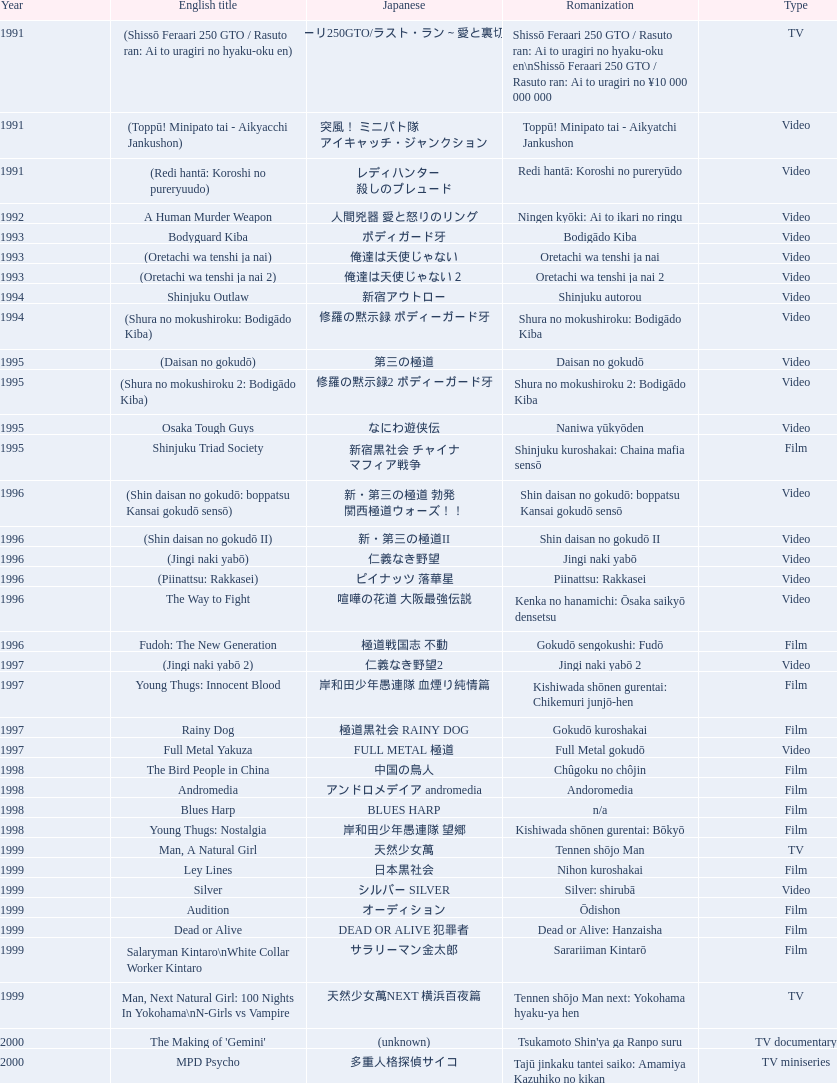Would you be able to parse every entry in this table? {'header': ['Year', 'English title', 'Japanese', 'Romanization', 'Type'], 'rows': [['1991', '(Shissō Feraari 250 GTO / Rasuto ran: Ai to uragiri no hyaku-oku en)', '疾走フェラーリ250GTO/ラスト・ラン～愛と裏切りの百億円', 'Shissō Feraari 250 GTO / Rasuto ran: Ai to uragiri no hyaku-oku en\\nShissō Feraari 250 GTO / Rasuto ran: Ai to uragiri no ¥10 000 000 000', 'TV'], ['1991', '(Toppū! Minipato tai - Aikyacchi Jankushon)', '突風！ ミニパト隊 アイキャッチ・ジャンクション', 'Toppū! Minipato tai - Aikyatchi Jankushon', 'Video'], ['1991', '(Redi hantā: Koroshi no pureryuudo)', 'レディハンター 殺しのプレュード', 'Redi hantā: Koroshi no pureryūdo', 'Video'], ['1992', 'A Human Murder Weapon', '人間兇器 愛と怒りのリング', 'Ningen kyōki: Ai to ikari no ringu', 'Video'], ['1993', 'Bodyguard Kiba', 'ボディガード牙', 'Bodigādo Kiba', 'Video'], ['1993', '(Oretachi wa tenshi ja nai)', '俺達は天使じゃない', 'Oretachi wa tenshi ja nai', 'Video'], ['1993', '(Oretachi wa tenshi ja nai 2)', '俺達は天使じゃない２', 'Oretachi wa tenshi ja nai 2', 'Video'], ['1994', 'Shinjuku Outlaw', '新宿アウトロー', 'Shinjuku autorou', 'Video'], ['1994', '(Shura no mokushiroku: Bodigādo Kiba)', '修羅の黙示録 ボディーガード牙', 'Shura no mokushiroku: Bodigādo Kiba', 'Video'], ['1995', '(Daisan no gokudō)', '第三の極道', 'Daisan no gokudō', 'Video'], ['1995', '(Shura no mokushiroku 2: Bodigādo Kiba)', '修羅の黙示録2 ボディーガード牙', 'Shura no mokushiroku 2: Bodigādo Kiba', 'Video'], ['1995', 'Osaka Tough Guys', 'なにわ遊侠伝', 'Naniwa yūkyōden', 'Video'], ['1995', 'Shinjuku Triad Society', '新宿黒社会 チャイナ マフィア戦争', 'Shinjuku kuroshakai: Chaina mafia sensō', 'Film'], ['1996', '(Shin daisan no gokudō: boppatsu Kansai gokudō sensō)', '新・第三の極道 勃発 関西極道ウォーズ！！', 'Shin daisan no gokudō: boppatsu Kansai gokudō sensō', 'Video'], ['1996', '(Shin daisan no gokudō II)', '新・第三の極道II', 'Shin daisan no gokudō II', 'Video'], ['1996', '(Jingi naki yabō)', '仁義なき野望', 'Jingi naki yabō', 'Video'], ['1996', '(Piinattsu: Rakkasei)', 'ピイナッツ 落華星', 'Piinattsu: Rakkasei', 'Video'], ['1996', 'The Way to Fight', '喧嘩の花道 大阪最強伝説', 'Kenka no hanamichi: Ōsaka saikyō densetsu', 'Video'], ['1996', 'Fudoh: The New Generation', '極道戦国志 不動', 'Gokudō sengokushi: Fudō', 'Film'], ['1997', '(Jingi naki yabō 2)', '仁義なき野望2', 'Jingi naki yabō 2', 'Video'], ['1997', 'Young Thugs: Innocent Blood', '岸和田少年愚連隊 血煙り純情篇', 'Kishiwada shōnen gurentai: Chikemuri junjō-hen', 'Film'], ['1997', 'Rainy Dog', '極道黒社会 RAINY DOG', 'Gokudō kuroshakai', 'Film'], ['1997', 'Full Metal Yakuza', 'FULL METAL 極道', 'Full Metal gokudō', 'Video'], ['1998', 'The Bird People in China', '中国の鳥人', 'Chûgoku no chôjin', 'Film'], ['1998', 'Andromedia', 'アンドロメデイア andromedia', 'Andoromedia', 'Film'], ['1998', 'Blues Harp', 'BLUES HARP', 'n/a', 'Film'], ['1998', 'Young Thugs: Nostalgia', '岸和田少年愚連隊 望郷', 'Kishiwada shōnen gurentai: Bōkyō', 'Film'], ['1999', 'Man, A Natural Girl', '天然少女萬', 'Tennen shōjo Man', 'TV'], ['1999', 'Ley Lines', '日本黒社会', 'Nihon kuroshakai', 'Film'], ['1999', 'Silver', 'シルバー SILVER', 'Silver: shirubā', 'Video'], ['1999', 'Audition', 'オーディション', 'Ōdishon', 'Film'], ['1999', 'Dead or Alive', 'DEAD OR ALIVE 犯罪者', 'Dead or Alive: Hanzaisha', 'Film'], ['1999', 'Salaryman Kintaro\\nWhite Collar Worker Kintaro', 'サラリーマン金太郎', 'Sarariiman Kintarō', 'Film'], ['1999', 'Man, Next Natural Girl: 100 Nights In Yokohama\\nN-Girls vs Vampire', '天然少女萬NEXT 横浜百夜篇', 'Tennen shōjo Man next: Yokohama hyaku-ya hen', 'TV'], ['2000', "The Making of 'Gemini'", '(unknown)', "Tsukamoto Shin'ya ga Ranpo suru", 'TV documentary'], ['2000', 'MPD Psycho', '多重人格探偵サイコ', 'Tajū jinkaku tantei saiko: Amamiya Kazuhiko no kikan', 'TV miniseries'], ['2000', 'The City of Lost Souls\\nThe City of Strangers\\nThe Hazard City', '漂流街 THE HAZARD CITY', 'Hyōryū-gai', 'Film'], ['2000', 'The Guys from Paradise', '天国から来た男たち', 'Tengoku kara kita otoko-tachi', 'Film'], ['2000', 'Dead or Alive 2: Birds\\nDead or Alive 2: Runaway', 'DEAD OR ALIVE 2 逃亡者', 'Dead or Alive 2: Tōbōsha', 'Film'], ['2001', '(Kikuchi-jō monogatari: sakimori-tachi no uta)', '鞠智城物語 防人たちの唄', 'Kikuchi-jō monogatari: sakimori-tachi no uta', 'Film'], ['2001', '(Zuiketsu gensō: Tonkararin yume densetsu)', '隧穴幻想 トンカラリン夢伝説', 'Zuiketsu gensō: Tonkararin yume densetsu', 'Film'], ['2001', 'Family', 'FAMILY', 'n/a', 'Film'], ['2001', 'Visitor Q', 'ビジターQ', 'Bijitā Q', 'Video'], ['2001', 'Ichi the Killer', '殺し屋1', 'Koroshiya 1', 'Film'], ['2001', 'Agitator', '荒ぶる魂たち', 'Araburu tamashii-tachi', 'Film'], ['2001', 'The Happiness of the Katakuris', 'カタクリ家の幸福', 'Katakuri-ke no kōfuku', 'Film'], ['2002', 'Dead or Alive: Final', 'DEAD OR ALIVE FINAL', 'n/a', 'Film'], ['2002', '(Onna kunishū ikki)', 'おんな 国衆一揆', 'Onna kunishū ikki', '(unknown)'], ['2002', 'Sabu', 'SABU さぶ', 'Sabu', 'TV'], ['2002', 'Graveyard of Honor', '新・仁義の墓場', 'Shin jingi no hakaba', 'Film'], ['2002', 'Shangri-La', '金融破滅ニッポン 桃源郷の人々', "Kin'yū hametsu Nippon: Tōgenkyō no hito-bito", 'Film'], ['2002', 'Pandōra', 'パンドーラ', 'Pandōra', 'Music video'], ['2002', 'Deadly Outlaw: Rekka\\nViolent Fire', '実録・安藤昇侠道（アウトロー）伝 烈火', 'Jitsuroku Andō Noboru kyōdō-den: Rekka', 'Film'], ['2002', 'Pāto-taimu tantei', 'パートタイム探偵', 'Pāto-taimu tantei', 'TV series'], ['2003', 'The Man in White', '許されざる者', 'Yurusarezaru mono', 'Film'], ['2003', 'Gozu', '極道恐怖大劇場 牛頭 GOZU', 'Gokudō kyōfu dai-gekijō: Gozu', 'Film'], ['2003', 'Yakuza Demon', '鬼哭 kikoku', 'Kikoku', 'Video'], ['2003', 'Kōshōnin', '交渉人', 'Kōshōnin', 'TV'], ['2003', "One Missed Call\\nYou've Got a Call", '着信アリ', 'Chakushin Ari', 'Film'], ['2004', 'Zebraman', 'ゼブラーマン', 'Zeburāman', 'Film'], ['2004', 'Pāto-taimu tantei 2', 'パートタイム探偵2', 'Pāto-taimu tantei 2', 'TV'], ['2004', 'Box segment in Three... Extremes', 'BOX（『美しい夜、残酷な朝』）', 'Saam gaang yi', 'Segment in feature film'], ['2004', 'Izo', 'IZO', 'IZO', 'Film'], ['2005', 'Ultraman Max', 'ウルトラマンマックス', 'Urutoraman Makkusu', 'Episodes 15 and 16 from TV tokusatsu series'], ['2005', 'The Great Yokai War', '妖怪大戦争', 'Yokai Daisenso', 'Film'], ['2006', 'Big Bang Love, Juvenile A\\n4.6 Billion Years of Love', '46億年の恋', '46-okunen no koi', 'Film'], ['2006', 'Waru', 'WARU', 'Waru', 'Film'], ['2006', 'Imprint episode from Masters of Horror', 'インプリント ～ぼっけえ、きょうてえ～', 'Inpurinto ~bokke kyote~', 'TV episode'], ['2006', 'Waru: kanketsu-hen', '', 'Waru: kanketsu-hen', 'Video'], ['2006', 'Sun Scarred', '太陽の傷', 'Taiyo no kizu', 'Film'], ['2007', 'Sukiyaki Western Django', 'スキヤキ・ウエスタン ジャンゴ', 'Sukiyaki wesutān jango', 'Film'], ['2007', 'Crows Zero', 'クローズZERO', 'Kurōzu Zero', 'Film'], ['2007', 'Like a Dragon', '龍が如く 劇場版', 'Ryu ga Gotoku Gekijōban', 'Film'], ['2007', 'Zatoichi', '座頭市', 'Zatōichi', 'Stageplay'], ['2007', 'Detective Story', '探偵物語', 'Tantei monogatari', 'Film'], ['2008', "God's Puzzle", '神様のパズル', 'Kamisama no pazuru', 'Film'], ['2008', 'K-tai Investigator 7', 'ケータイ捜査官7', 'Keitai Sōsakan 7', 'TV'], ['2009', 'Yatterman', 'ヤッターマン', 'Yattaaman', 'Film'], ['2009', 'Crows Zero 2', 'クローズZERO 2', 'Kurōzu Zero 2', 'Film'], ['2010', 'Thirteen Assassins', '十三人の刺客', 'Jûsan-nin no shikaku', 'Film'], ['2010', 'Zebraman 2: Attack on Zebra City', 'ゼブラーマン -ゼブラシティの逆襲', 'Zeburāman -Zebura Shiti no Gyakushū', 'Film'], ['2011', 'Ninja Kids!!!', '忍たま乱太郎', 'Nintama Rantarō', 'Film'], ['2011', 'Hara-Kiri: Death of a Samurai', '一命', 'Ichimei', 'Film'], ['2012', 'Ace Attorney', '逆転裁判', 'Gyakuten Saiban', 'Film'], ['2012', "For Love's Sake", '愛と誠', 'Ai to makoto', 'Film'], ['2012', 'Lesson of the Evil', '悪の教典', 'Aku no Kyōten', 'Film'], ['2013', 'Shield of Straw', '藁の楯', 'Wara no Tate', 'Film'], ['2013', 'The Mole Song: Undercover Agent Reiji', '土竜の唄\u3000潜入捜査官 REIJI', 'Mogura no uta – sennyu sosakan: Reiji', 'Film']]} How many years is the chart for? 23. 